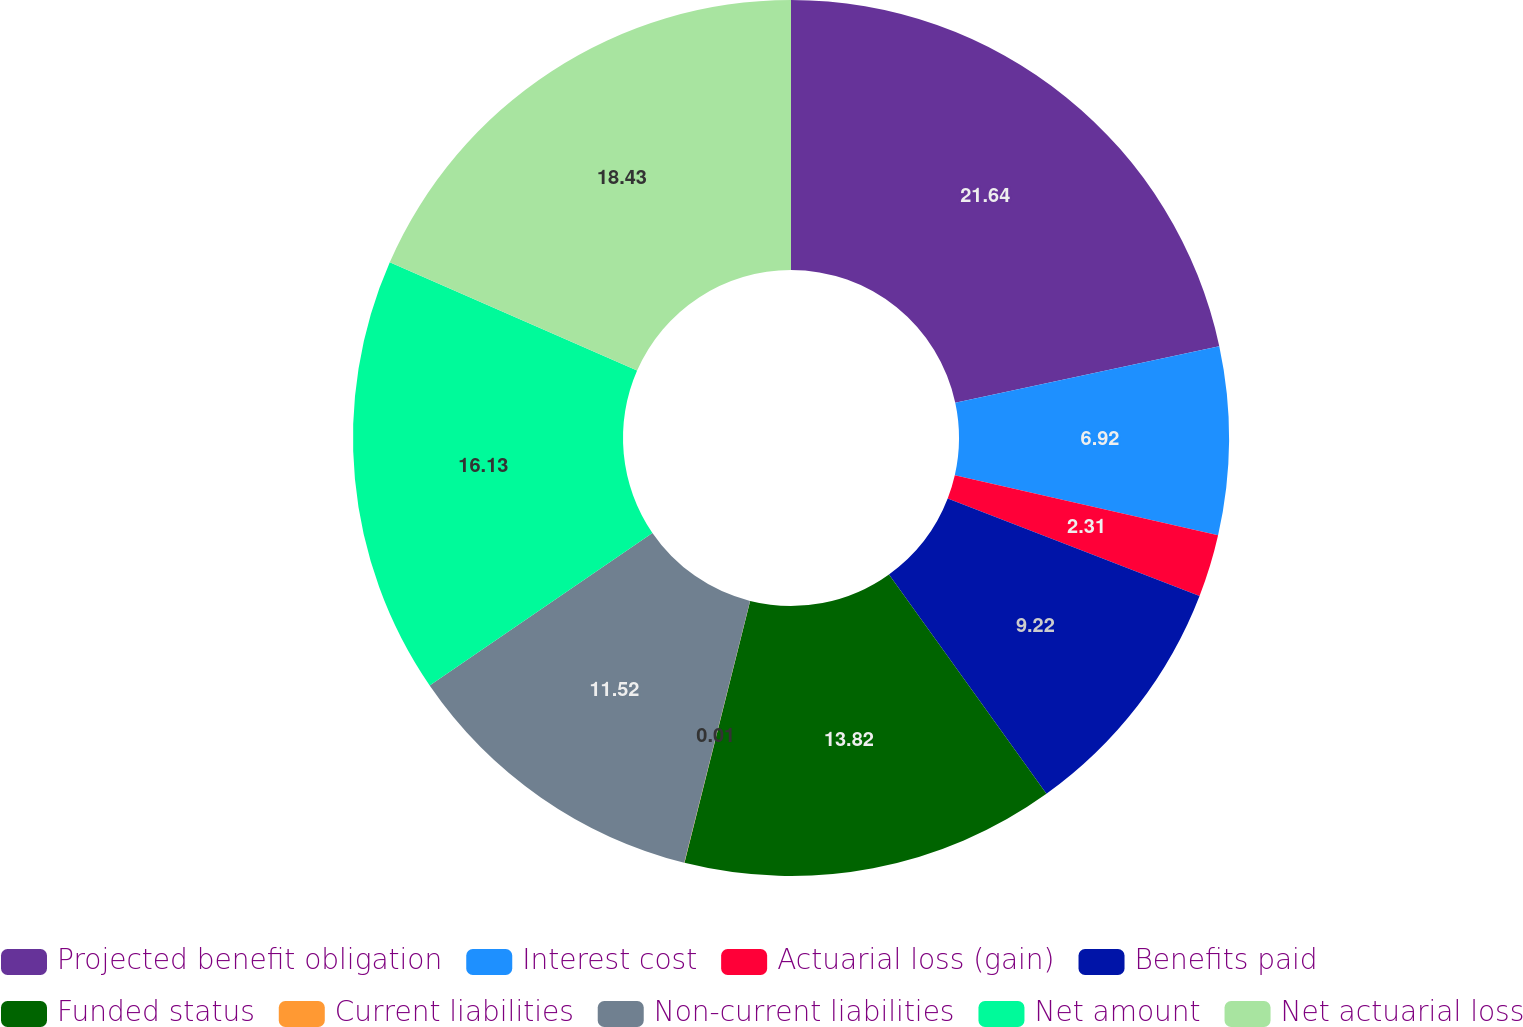Convert chart. <chart><loc_0><loc_0><loc_500><loc_500><pie_chart><fcel>Projected benefit obligation<fcel>Interest cost<fcel>Actuarial loss (gain)<fcel>Benefits paid<fcel>Funded status<fcel>Current liabilities<fcel>Non-current liabilities<fcel>Net amount<fcel>Net actuarial loss<nl><fcel>21.64%<fcel>6.92%<fcel>2.31%<fcel>9.22%<fcel>13.82%<fcel>0.01%<fcel>11.52%<fcel>16.13%<fcel>18.43%<nl></chart> 